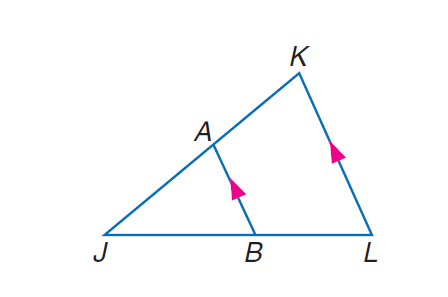Answer the mathemtical geometry problem and directly provide the correct option letter.
Question: If J L = 27, B L = 9, and J K = 18, find J A.
Choices: A: 9 B: 12 C: 13.5 D: 18 B 